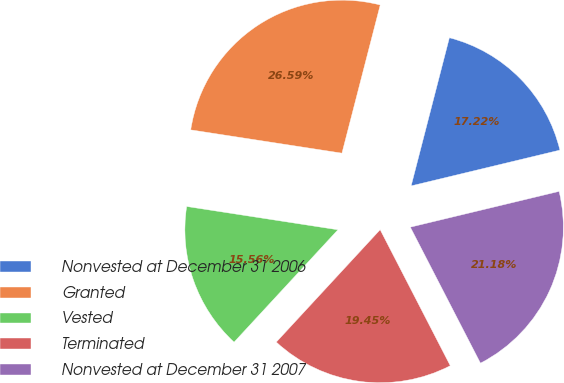Convert chart to OTSL. <chart><loc_0><loc_0><loc_500><loc_500><pie_chart><fcel>Nonvested at December 31 2006<fcel>Granted<fcel>Vested<fcel>Terminated<fcel>Nonvested at December 31 2007<nl><fcel>17.22%<fcel>26.59%<fcel>15.56%<fcel>19.45%<fcel>21.18%<nl></chart> 